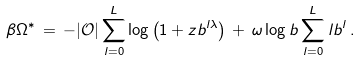<formula> <loc_0><loc_0><loc_500><loc_500>\beta \Omega ^ { * } \, = \, - | { \mathcal { O } } | \sum _ { l = 0 } ^ { L } \log \left ( 1 + z b ^ { l \lambda } \right ) \, + \, \omega \log b \sum _ { l = 0 } ^ { L } l b ^ { l } \, .</formula> 